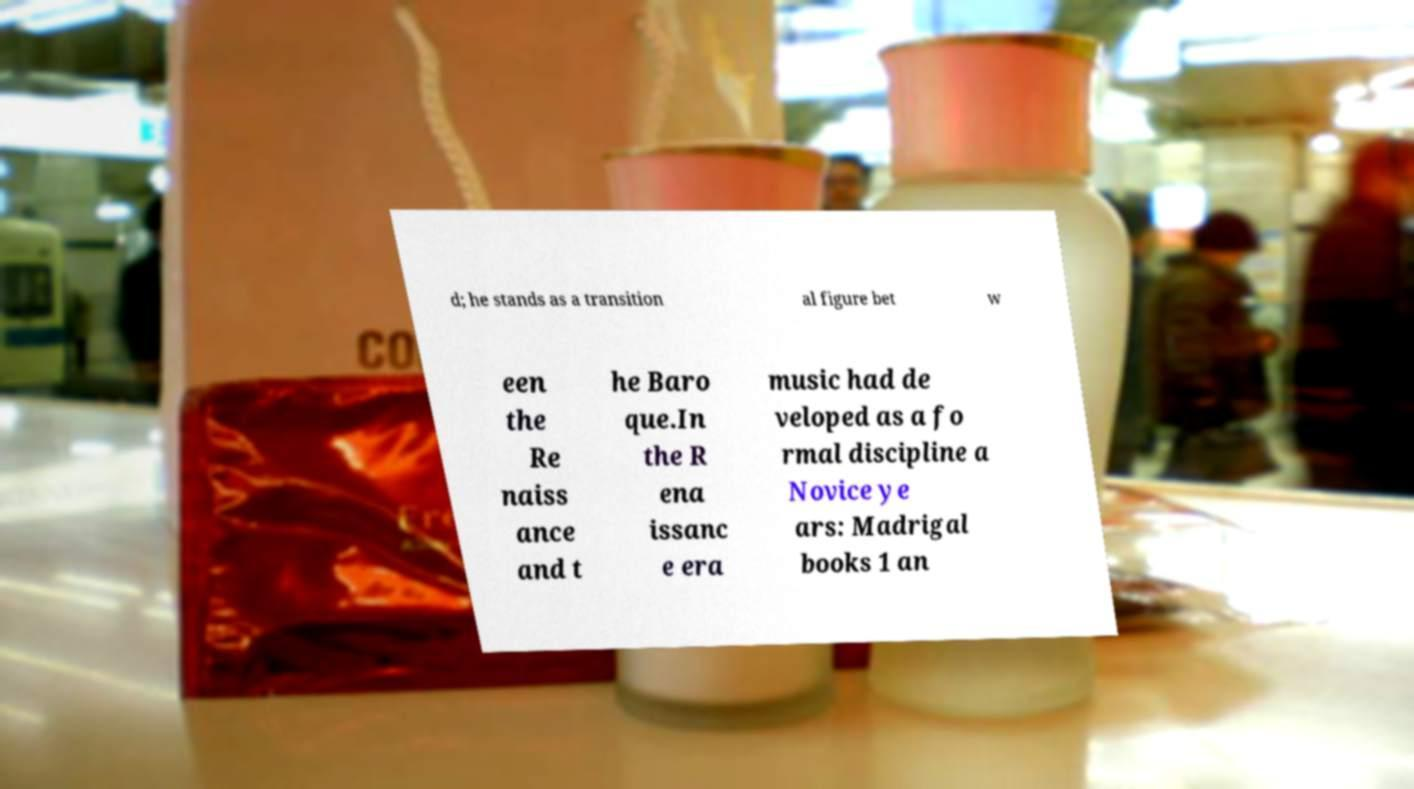I need the written content from this picture converted into text. Can you do that? d; he stands as a transition al figure bet w een the Re naiss ance and t he Baro que.In the R ena issanc e era music had de veloped as a fo rmal discipline a Novice ye ars: Madrigal books 1 an 